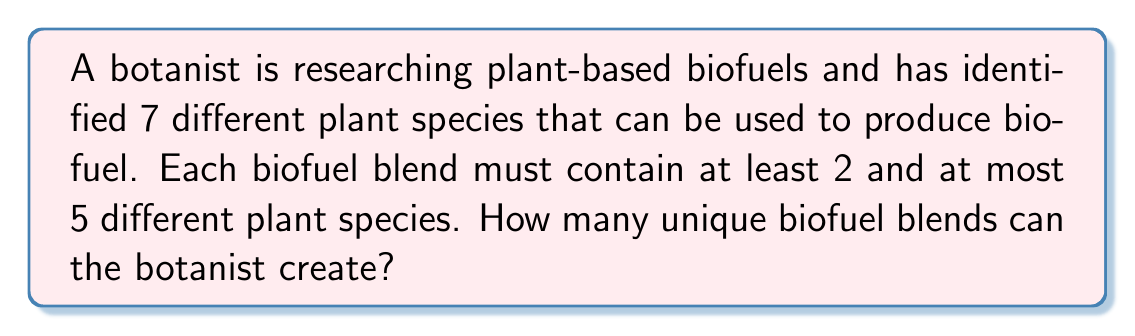Could you help me with this problem? To solve this problem, we need to use the combination formula and sum the number of possible combinations for blends containing 2, 3, 4, and 5 plant species.

1. For blends with 2 species:
   $${7 \choose 2} = \frac{7!}{2!(7-2)!} = \frac{7 \cdot 6}{2 \cdot 1} = 21$$

2. For blends with 3 species:
   $${7 \choose 3} = \frac{7!}{3!(7-3)!} = \frac{7 \cdot 6 \cdot 5}{3 \cdot 2 \cdot 1} = 35$$

3. For blends with 4 species:
   $${7 \choose 4} = \frac{7!}{4!(7-4)!} = \frac{7 \cdot 6 \cdot 5 \cdot 4}{4 \cdot 3 \cdot 2 \cdot 1} = 35$$

4. For blends with 5 species:
   $${7 \choose 5} = \frac{7!}{5!(7-5)!} = \frac{7 \cdot 6}{2 \cdot 1} = 21$$

5. Sum all the possible combinations:
   $$21 + 35 + 35 + 21 = 112$$

Therefore, the total number of unique biofuel blends the botanist can create is 112.
Answer: 112 